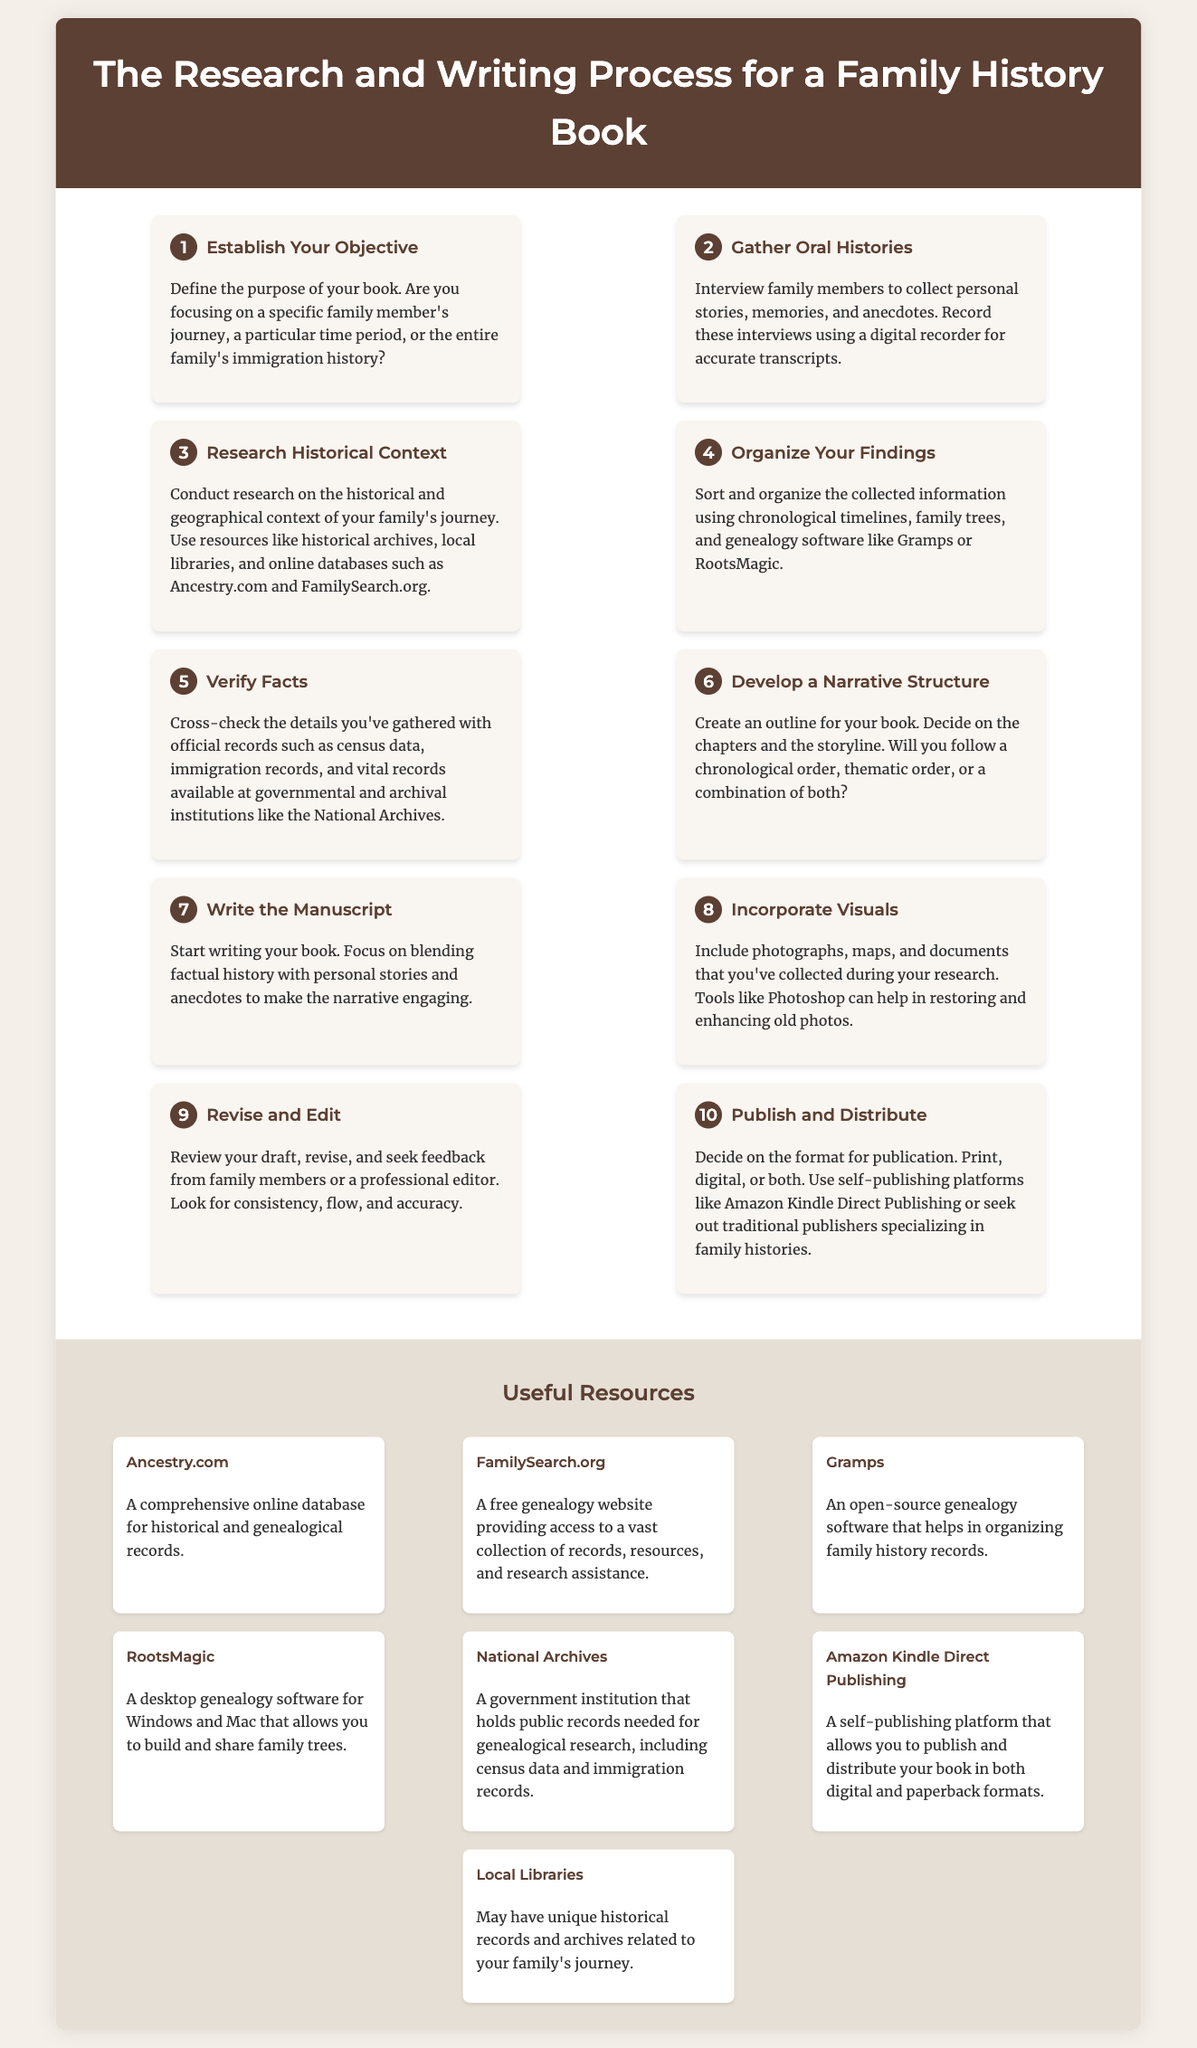what is the title of the document? The title, displayed prominently at the top of the infographic, introduces the subject of the document.
Answer: The Research and Writing Process for a Family History Book how many steps are outlined in the process? The number of steps is indicated by the sequential organization of the content, with each step clearly labeled.
Answer: 10 what is the first step in the process? The first step provides a clear starting point for the process described in the document.
Answer: Establish Your Objective which software is suggested for organizing findings? The software mentioned in the context of organizing family history records is emphasized in the relevant step of the process.
Answer: Gramps what should you include in your manuscript to enhance it? This aspect is noted in the step about visuals, highlighting the importance of additional elements in the narrative.
Answer: Visuals who is responsible for reviewing the draft? The person or group indicated in the step about revising and editing is crucial for the quality of the manuscript.
Answer: Family members or a professional editor which self-publishing platform is mentioned for distribution? The specific platform stated in the final step signifies a method for getting the book to readers.
Answer: Amazon Kindle Direct Publishing what is the purpose of interviewing family members? This purpose is described in the step about gathering oral histories and is integral to the research process.
Answer: Collect personal stories, memories, and anecdotes which type of historical records should facts be verified against? The context provides suggestions for official records that help in ensuring the accuracy of gathered information.
Answer: Immigration records what is the suggested action after writing the manuscript? The logical next step is outlined following the writing process, focusing on the refinement of the draft.
Answer: Revise and Edit 